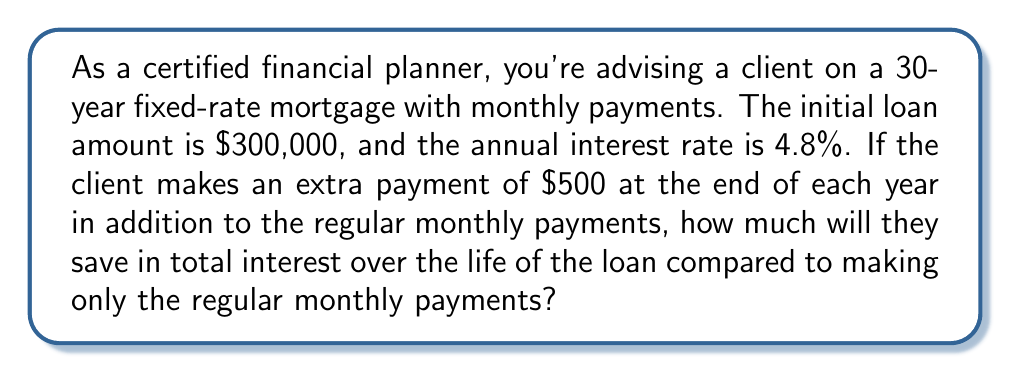Give your solution to this math problem. Let's approach this step-by-step:

1) First, calculate the regular monthly payment:
   Annual interest rate: $r = 4.8\% = 0.048$
   Monthly interest rate: $i = \frac{r}{12} = 0.004$
   Number of monthly payments: $n = 30 \times 12 = 360$
   Loan amount: $P = 300,000$

   Monthly payment formula: $M = P \frac{i(1+i)^n}{(1+i)^n - 1}$

   $M = 300,000 \frac{0.004(1+0.004)^{360}}{(1+0.004)^{360} - 1} \approx 1,574.45$

2) Calculate total payments without extra contributions:
   $1,574.45 \times 360 = 566,802$
   Total interest = $566,802 - 300,000 = 266,802$

3) Now, model the loan with extra payments:
   Each year, an additional $500 is paid, reducing the principal.
   We can model this as a geometric sequence with 30 terms:
   $a_1 = 500, r = 1.048$ (growing at the annual interest rate)

   Sum of this geometric sequence: $S = 500 \frac{1-1.048^{30}}{1-1.048} \approx 32,020.69$

4) This means the extra payments effectively reduce the loan by $32,020.69.

5) Recalculate the loan with the reduced principal:
   New loan amount: $300,000 - 32,020.69 = 267,979.31$

   New monthly payment: 
   $M = 267,979.31 \frac{0.004(1+0.004)^{360}}{(1+0.004)^{360} - 1} \approx 1,406.69$

6) Total payments with extra contributions:
   $(1,406.69 \times 360) + (500 \times 30) = 506,408.40 + 15,000 = 521,408.40$
   New total interest = $521,408.40 - 300,000 = 221,408.40$

7) Interest saved:
   $266,802 - 221,408.40 = 45,393.60$
Answer: $45,393.60 